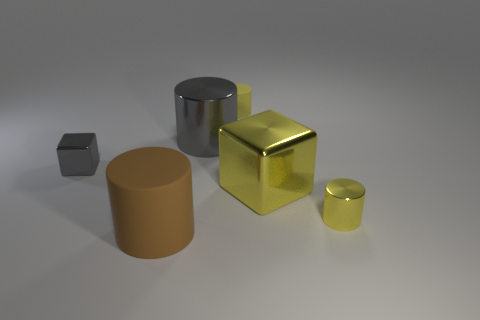Are there fewer small yellow things that are on the left side of the large yellow metallic block than yellow things that are on the left side of the big brown matte cylinder?
Your response must be concise. No. Is there anything else that is the same size as the brown cylinder?
Provide a succinct answer. Yes. The yellow metallic cylinder is what size?
Offer a very short reply. Small. What number of tiny objects are either green metal spheres or brown matte things?
Offer a terse response. 0. Is the size of the brown cylinder the same as the metallic cylinder that is in front of the gray shiny cylinder?
Provide a short and direct response. No. Is there any other thing that is the same shape as the tiny gray shiny object?
Your response must be concise. Yes. What number of large yellow shiny objects are there?
Provide a short and direct response. 1. How many brown things are large metal cylinders or blocks?
Make the answer very short. 0. Is the material of the small cylinder that is behind the tiny gray metal cube the same as the gray block?
Keep it short and to the point. No. How many other things are made of the same material as the big brown cylinder?
Make the answer very short. 1. 